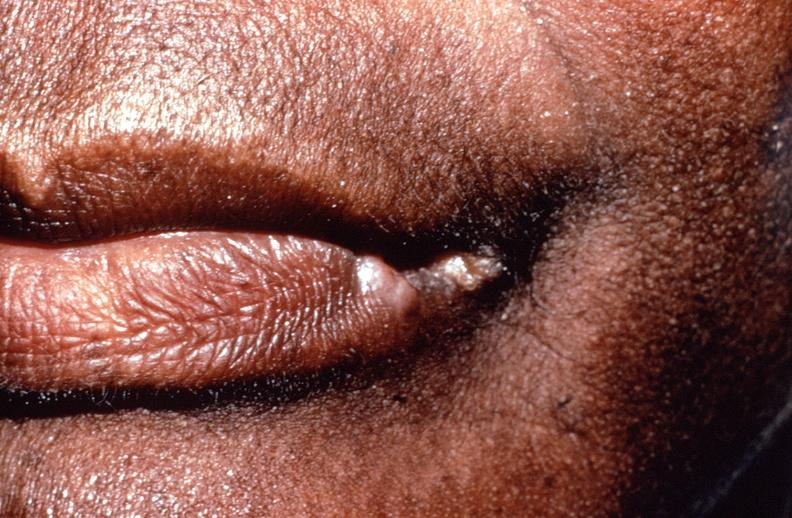s squamous cell carcinoma, lip remote, healed?
Answer the question using a single word or phrase. Yes 